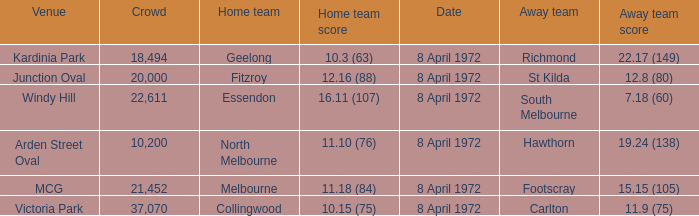Which Home team score has a Home team of geelong? 10.3 (63). 